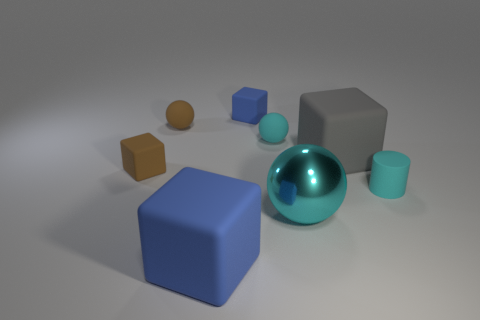How many cyan spheres must be subtracted to get 1 cyan spheres? 1 Subtract all brown blocks. How many blocks are left? 3 Subtract all large gray matte cubes. How many cubes are left? 3 Add 1 small blue blocks. How many objects exist? 9 Subtract all red blocks. Subtract all blue cylinders. How many blocks are left? 4 Subtract all cylinders. How many objects are left? 7 Subtract all tiny purple cubes. Subtract all matte cylinders. How many objects are left? 7 Add 1 large blue matte cubes. How many large blue matte cubes are left? 2 Add 6 red matte cylinders. How many red matte cylinders exist? 6 Subtract 0 purple balls. How many objects are left? 8 